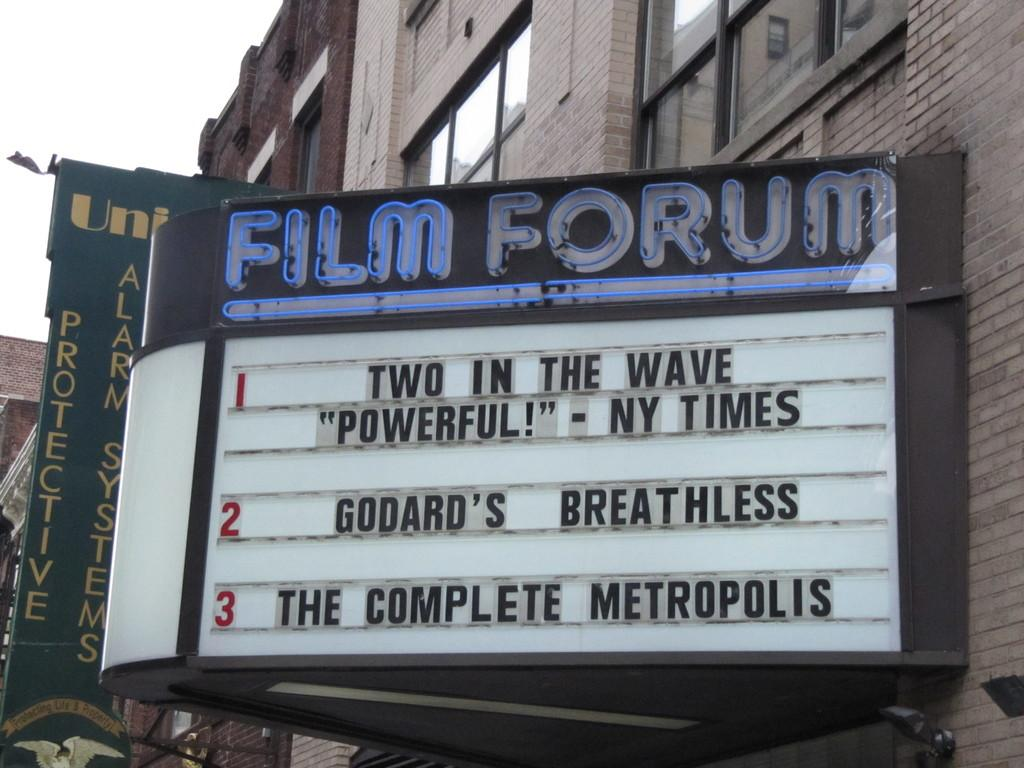What is hanging from the building in the image? There are two banners with text in the image. Where are the banners attached? The banners are attached to a building. What can be seen in the top left of the image? The sky is visible in the top left of the image. What is the color of the sky in the image? The sky is white in color. How many cherries are hanging from the banners in the image? There are no cherries present in the image; it only features banners with text attached to a building. 